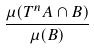Convert formula to latex. <formula><loc_0><loc_0><loc_500><loc_500>\frac { \mu ( T ^ { n } A \cap B ) } { \mu ( B ) }</formula> 